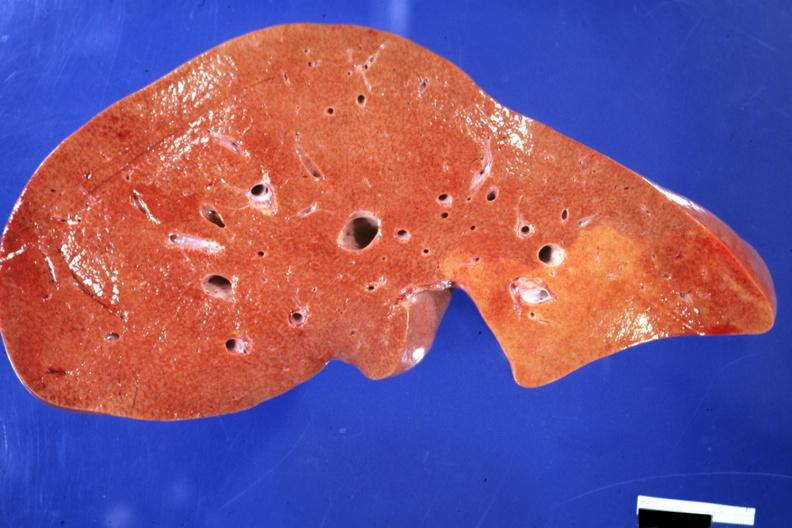does this image show frontal section typical enlarged fatty liver with focal nutmeg areas?
Answer the question using a single word or phrase. Yes 